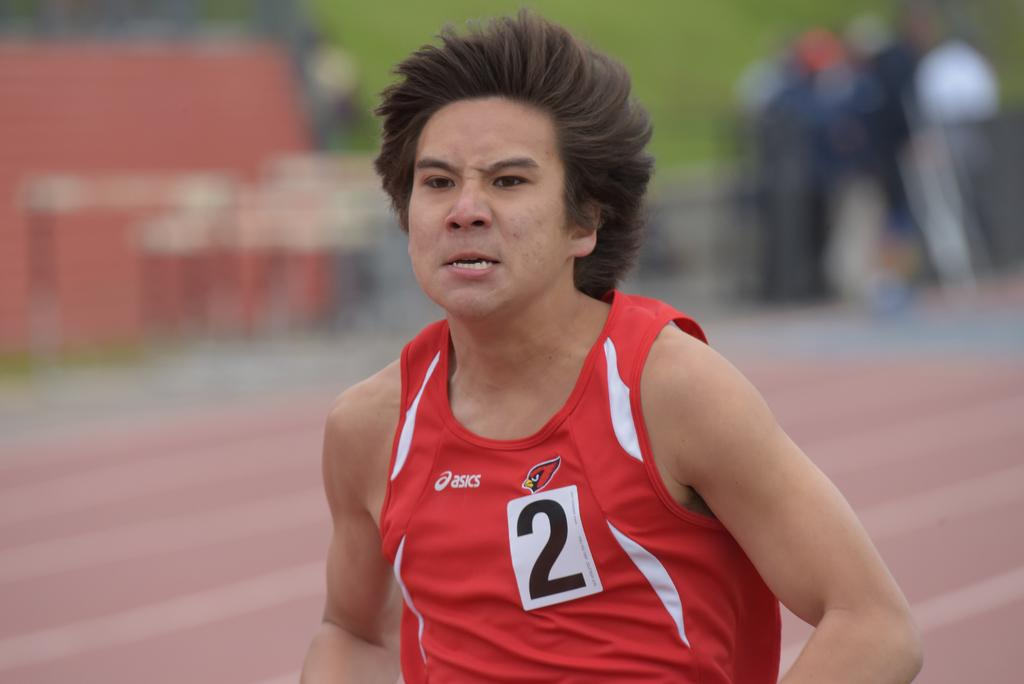What is the main subject of the image? There is a person in the image. Where is the person located in the image? The person is in the middle of the image. What type of teeth does the person have in the image? There is no information about the person's teeth in the image, so it cannot be determined. 